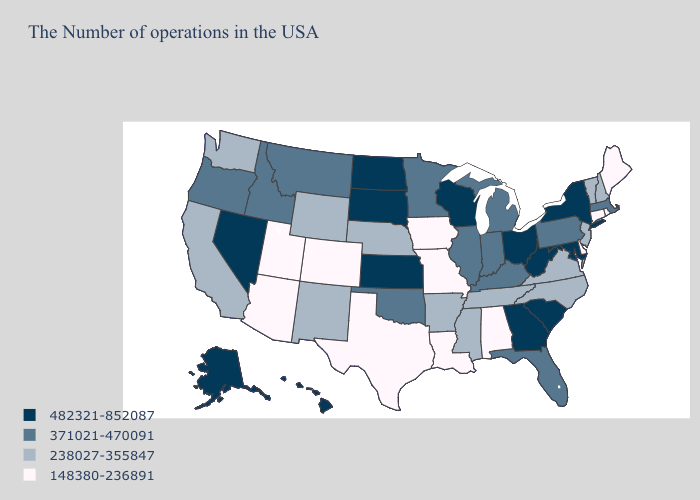Name the states that have a value in the range 148380-236891?
Short answer required. Maine, Rhode Island, Connecticut, Delaware, Alabama, Louisiana, Missouri, Iowa, Texas, Colorado, Utah, Arizona. What is the highest value in states that border Alabama?
Be succinct. 482321-852087. What is the value of Indiana?
Answer briefly. 371021-470091. Does Hawaii have a higher value than Maryland?
Write a very short answer. No. What is the value of Connecticut?
Be succinct. 148380-236891. What is the value of Michigan?
Short answer required. 371021-470091. Name the states that have a value in the range 238027-355847?
Short answer required. New Hampshire, Vermont, New Jersey, Virginia, North Carolina, Tennessee, Mississippi, Arkansas, Nebraska, Wyoming, New Mexico, California, Washington. Among the states that border Pennsylvania , which have the lowest value?
Give a very brief answer. Delaware. Among the states that border Virginia , which have the highest value?
Concise answer only. Maryland, West Virginia. Is the legend a continuous bar?
Concise answer only. No. Which states have the highest value in the USA?
Answer briefly. New York, Maryland, South Carolina, West Virginia, Ohio, Georgia, Wisconsin, Kansas, South Dakota, North Dakota, Nevada, Alaska, Hawaii. What is the value of Montana?
Be succinct. 371021-470091. Is the legend a continuous bar?
Keep it brief. No. Name the states that have a value in the range 238027-355847?
Keep it brief. New Hampshire, Vermont, New Jersey, Virginia, North Carolina, Tennessee, Mississippi, Arkansas, Nebraska, Wyoming, New Mexico, California, Washington. Does the map have missing data?
Be succinct. No. 